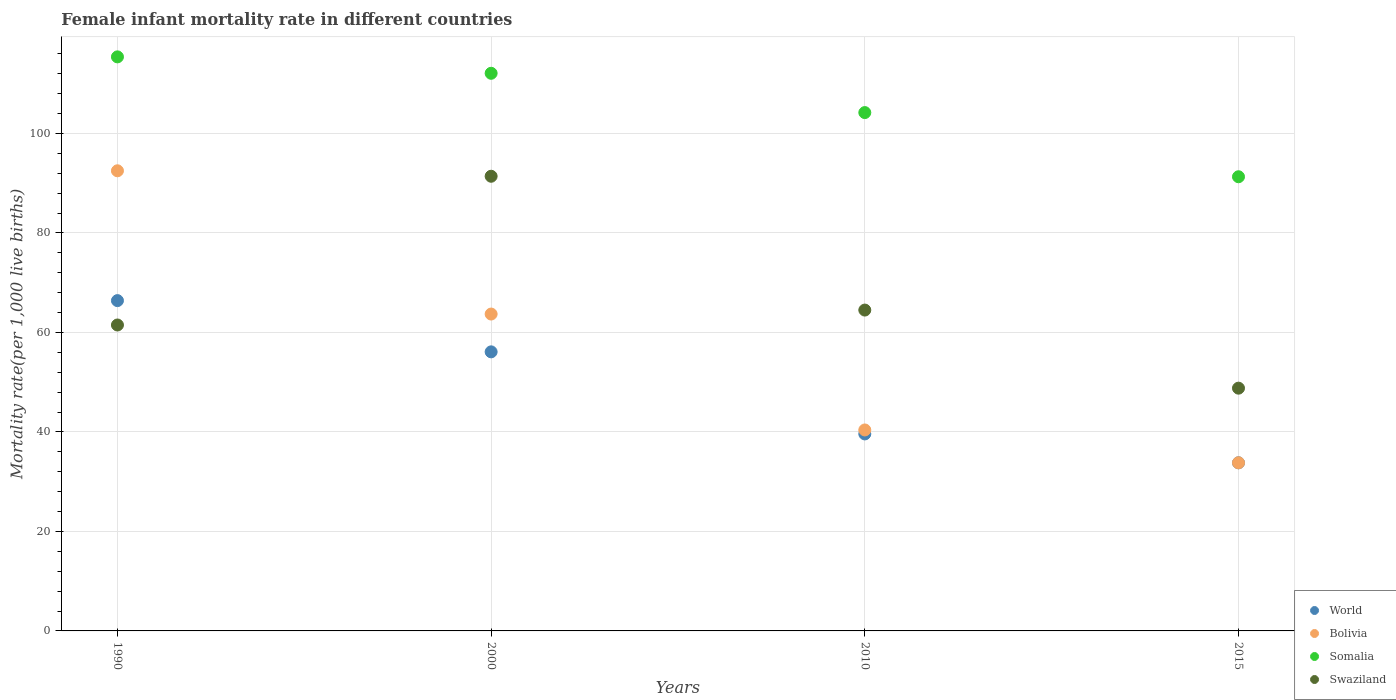How many different coloured dotlines are there?
Your response must be concise. 4. Is the number of dotlines equal to the number of legend labels?
Offer a very short reply. Yes. What is the female infant mortality rate in World in 2000?
Provide a short and direct response. 56.1. Across all years, what is the maximum female infant mortality rate in Bolivia?
Provide a succinct answer. 92.5. Across all years, what is the minimum female infant mortality rate in Somalia?
Keep it short and to the point. 91.3. In which year was the female infant mortality rate in Somalia maximum?
Your response must be concise. 1990. In which year was the female infant mortality rate in Bolivia minimum?
Make the answer very short. 2015. What is the total female infant mortality rate in Swaziland in the graph?
Your response must be concise. 266.2. What is the difference between the female infant mortality rate in Somalia in 2000 and that in 2010?
Offer a very short reply. 7.9. What is the difference between the female infant mortality rate in World in 1990 and the female infant mortality rate in Swaziland in 2010?
Provide a short and direct response. 1.9. What is the average female infant mortality rate in Somalia per year?
Make the answer very short. 105.75. In how many years, is the female infant mortality rate in Bolivia greater than 80?
Offer a very short reply. 1. What is the ratio of the female infant mortality rate in Swaziland in 1990 to that in 2000?
Your response must be concise. 0.67. Is the female infant mortality rate in Swaziland in 1990 less than that in 2010?
Provide a short and direct response. Yes. What is the difference between the highest and the second highest female infant mortality rate in Somalia?
Keep it short and to the point. 3.3. What is the difference between the highest and the lowest female infant mortality rate in Swaziland?
Your response must be concise. 42.6. In how many years, is the female infant mortality rate in Swaziland greater than the average female infant mortality rate in Swaziland taken over all years?
Provide a short and direct response. 1. Is the sum of the female infant mortality rate in Swaziland in 1990 and 2015 greater than the maximum female infant mortality rate in Bolivia across all years?
Provide a short and direct response. Yes. Is it the case that in every year, the sum of the female infant mortality rate in World and female infant mortality rate in Somalia  is greater than the female infant mortality rate in Bolivia?
Your response must be concise. Yes. Is the female infant mortality rate in Swaziland strictly less than the female infant mortality rate in Somalia over the years?
Your answer should be compact. Yes. Are the values on the major ticks of Y-axis written in scientific E-notation?
Ensure brevity in your answer.  No. Does the graph contain any zero values?
Your answer should be compact. No. Does the graph contain grids?
Provide a succinct answer. Yes. Where does the legend appear in the graph?
Your response must be concise. Bottom right. What is the title of the graph?
Your answer should be very brief. Female infant mortality rate in different countries. What is the label or title of the Y-axis?
Keep it short and to the point. Mortality rate(per 1,0 live births). What is the Mortality rate(per 1,000 live births) of World in 1990?
Your answer should be compact. 66.4. What is the Mortality rate(per 1,000 live births) of Bolivia in 1990?
Your answer should be compact. 92.5. What is the Mortality rate(per 1,000 live births) of Somalia in 1990?
Provide a short and direct response. 115.4. What is the Mortality rate(per 1,000 live births) of Swaziland in 1990?
Offer a terse response. 61.5. What is the Mortality rate(per 1,000 live births) in World in 2000?
Offer a terse response. 56.1. What is the Mortality rate(per 1,000 live births) in Bolivia in 2000?
Your answer should be very brief. 63.7. What is the Mortality rate(per 1,000 live births) of Somalia in 2000?
Your answer should be compact. 112.1. What is the Mortality rate(per 1,000 live births) of Swaziland in 2000?
Offer a very short reply. 91.4. What is the Mortality rate(per 1,000 live births) of World in 2010?
Your answer should be very brief. 39.6. What is the Mortality rate(per 1,000 live births) in Bolivia in 2010?
Offer a very short reply. 40.4. What is the Mortality rate(per 1,000 live births) of Somalia in 2010?
Offer a terse response. 104.2. What is the Mortality rate(per 1,000 live births) of Swaziland in 2010?
Your response must be concise. 64.5. What is the Mortality rate(per 1,000 live births) in World in 2015?
Your response must be concise. 33.8. What is the Mortality rate(per 1,000 live births) in Bolivia in 2015?
Keep it short and to the point. 33.8. What is the Mortality rate(per 1,000 live births) in Somalia in 2015?
Provide a succinct answer. 91.3. What is the Mortality rate(per 1,000 live births) of Swaziland in 2015?
Offer a very short reply. 48.8. Across all years, what is the maximum Mortality rate(per 1,000 live births) of World?
Provide a succinct answer. 66.4. Across all years, what is the maximum Mortality rate(per 1,000 live births) in Bolivia?
Offer a terse response. 92.5. Across all years, what is the maximum Mortality rate(per 1,000 live births) of Somalia?
Keep it short and to the point. 115.4. Across all years, what is the maximum Mortality rate(per 1,000 live births) of Swaziland?
Provide a succinct answer. 91.4. Across all years, what is the minimum Mortality rate(per 1,000 live births) of World?
Offer a very short reply. 33.8. Across all years, what is the minimum Mortality rate(per 1,000 live births) of Bolivia?
Your response must be concise. 33.8. Across all years, what is the minimum Mortality rate(per 1,000 live births) of Somalia?
Keep it short and to the point. 91.3. Across all years, what is the minimum Mortality rate(per 1,000 live births) in Swaziland?
Offer a very short reply. 48.8. What is the total Mortality rate(per 1,000 live births) of World in the graph?
Ensure brevity in your answer.  195.9. What is the total Mortality rate(per 1,000 live births) of Bolivia in the graph?
Ensure brevity in your answer.  230.4. What is the total Mortality rate(per 1,000 live births) of Somalia in the graph?
Your answer should be compact. 423. What is the total Mortality rate(per 1,000 live births) of Swaziland in the graph?
Your answer should be very brief. 266.2. What is the difference between the Mortality rate(per 1,000 live births) in Bolivia in 1990 and that in 2000?
Your answer should be very brief. 28.8. What is the difference between the Mortality rate(per 1,000 live births) of Somalia in 1990 and that in 2000?
Offer a very short reply. 3.3. What is the difference between the Mortality rate(per 1,000 live births) of Swaziland in 1990 and that in 2000?
Make the answer very short. -29.9. What is the difference between the Mortality rate(per 1,000 live births) in World in 1990 and that in 2010?
Give a very brief answer. 26.8. What is the difference between the Mortality rate(per 1,000 live births) of Bolivia in 1990 and that in 2010?
Ensure brevity in your answer.  52.1. What is the difference between the Mortality rate(per 1,000 live births) of World in 1990 and that in 2015?
Your answer should be compact. 32.6. What is the difference between the Mortality rate(per 1,000 live births) in Bolivia in 1990 and that in 2015?
Your answer should be compact. 58.7. What is the difference between the Mortality rate(per 1,000 live births) of Somalia in 1990 and that in 2015?
Your answer should be compact. 24.1. What is the difference between the Mortality rate(per 1,000 live births) in Bolivia in 2000 and that in 2010?
Your response must be concise. 23.3. What is the difference between the Mortality rate(per 1,000 live births) in Swaziland in 2000 and that in 2010?
Your response must be concise. 26.9. What is the difference between the Mortality rate(per 1,000 live births) in World in 2000 and that in 2015?
Your answer should be very brief. 22.3. What is the difference between the Mortality rate(per 1,000 live births) of Bolivia in 2000 and that in 2015?
Keep it short and to the point. 29.9. What is the difference between the Mortality rate(per 1,000 live births) of Somalia in 2000 and that in 2015?
Your answer should be compact. 20.8. What is the difference between the Mortality rate(per 1,000 live births) of Swaziland in 2000 and that in 2015?
Provide a succinct answer. 42.6. What is the difference between the Mortality rate(per 1,000 live births) of Bolivia in 2010 and that in 2015?
Your response must be concise. 6.6. What is the difference between the Mortality rate(per 1,000 live births) in Somalia in 2010 and that in 2015?
Offer a terse response. 12.9. What is the difference between the Mortality rate(per 1,000 live births) of World in 1990 and the Mortality rate(per 1,000 live births) of Bolivia in 2000?
Provide a succinct answer. 2.7. What is the difference between the Mortality rate(per 1,000 live births) of World in 1990 and the Mortality rate(per 1,000 live births) of Somalia in 2000?
Ensure brevity in your answer.  -45.7. What is the difference between the Mortality rate(per 1,000 live births) of Bolivia in 1990 and the Mortality rate(per 1,000 live births) of Somalia in 2000?
Offer a very short reply. -19.6. What is the difference between the Mortality rate(per 1,000 live births) of World in 1990 and the Mortality rate(per 1,000 live births) of Bolivia in 2010?
Give a very brief answer. 26. What is the difference between the Mortality rate(per 1,000 live births) in World in 1990 and the Mortality rate(per 1,000 live births) in Somalia in 2010?
Offer a very short reply. -37.8. What is the difference between the Mortality rate(per 1,000 live births) in World in 1990 and the Mortality rate(per 1,000 live births) in Swaziland in 2010?
Keep it short and to the point. 1.9. What is the difference between the Mortality rate(per 1,000 live births) of Bolivia in 1990 and the Mortality rate(per 1,000 live births) of Somalia in 2010?
Offer a terse response. -11.7. What is the difference between the Mortality rate(per 1,000 live births) of Bolivia in 1990 and the Mortality rate(per 1,000 live births) of Swaziland in 2010?
Offer a very short reply. 28. What is the difference between the Mortality rate(per 1,000 live births) in Somalia in 1990 and the Mortality rate(per 1,000 live births) in Swaziland in 2010?
Provide a succinct answer. 50.9. What is the difference between the Mortality rate(per 1,000 live births) of World in 1990 and the Mortality rate(per 1,000 live births) of Bolivia in 2015?
Your answer should be very brief. 32.6. What is the difference between the Mortality rate(per 1,000 live births) of World in 1990 and the Mortality rate(per 1,000 live births) of Somalia in 2015?
Keep it short and to the point. -24.9. What is the difference between the Mortality rate(per 1,000 live births) in Bolivia in 1990 and the Mortality rate(per 1,000 live births) in Swaziland in 2015?
Ensure brevity in your answer.  43.7. What is the difference between the Mortality rate(per 1,000 live births) of Somalia in 1990 and the Mortality rate(per 1,000 live births) of Swaziland in 2015?
Your answer should be compact. 66.6. What is the difference between the Mortality rate(per 1,000 live births) in World in 2000 and the Mortality rate(per 1,000 live births) in Bolivia in 2010?
Offer a very short reply. 15.7. What is the difference between the Mortality rate(per 1,000 live births) in World in 2000 and the Mortality rate(per 1,000 live births) in Somalia in 2010?
Your response must be concise. -48.1. What is the difference between the Mortality rate(per 1,000 live births) in Bolivia in 2000 and the Mortality rate(per 1,000 live births) in Somalia in 2010?
Keep it short and to the point. -40.5. What is the difference between the Mortality rate(per 1,000 live births) of Somalia in 2000 and the Mortality rate(per 1,000 live births) of Swaziland in 2010?
Your answer should be very brief. 47.6. What is the difference between the Mortality rate(per 1,000 live births) in World in 2000 and the Mortality rate(per 1,000 live births) in Bolivia in 2015?
Give a very brief answer. 22.3. What is the difference between the Mortality rate(per 1,000 live births) in World in 2000 and the Mortality rate(per 1,000 live births) in Somalia in 2015?
Provide a succinct answer. -35.2. What is the difference between the Mortality rate(per 1,000 live births) of World in 2000 and the Mortality rate(per 1,000 live births) of Swaziland in 2015?
Give a very brief answer. 7.3. What is the difference between the Mortality rate(per 1,000 live births) in Bolivia in 2000 and the Mortality rate(per 1,000 live births) in Somalia in 2015?
Provide a succinct answer. -27.6. What is the difference between the Mortality rate(per 1,000 live births) of Somalia in 2000 and the Mortality rate(per 1,000 live births) of Swaziland in 2015?
Keep it short and to the point. 63.3. What is the difference between the Mortality rate(per 1,000 live births) of World in 2010 and the Mortality rate(per 1,000 live births) of Somalia in 2015?
Keep it short and to the point. -51.7. What is the difference between the Mortality rate(per 1,000 live births) of Bolivia in 2010 and the Mortality rate(per 1,000 live births) of Somalia in 2015?
Keep it short and to the point. -50.9. What is the difference between the Mortality rate(per 1,000 live births) of Bolivia in 2010 and the Mortality rate(per 1,000 live births) of Swaziland in 2015?
Offer a very short reply. -8.4. What is the difference between the Mortality rate(per 1,000 live births) in Somalia in 2010 and the Mortality rate(per 1,000 live births) in Swaziland in 2015?
Keep it short and to the point. 55.4. What is the average Mortality rate(per 1,000 live births) in World per year?
Your answer should be compact. 48.98. What is the average Mortality rate(per 1,000 live births) of Bolivia per year?
Ensure brevity in your answer.  57.6. What is the average Mortality rate(per 1,000 live births) in Somalia per year?
Keep it short and to the point. 105.75. What is the average Mortality rate(per 1,000 live births) in Swaziland per year?
Ensure brevity in your answer.  66.55. In the year 1990, what is the difference between the Mortality rate(per 1,000 live births) of World and Mortality rate(per 1,000 live births) of Bolivia?
Your answer should be very brief. -26.1. In the year 1990, what is the difference between the Mortality rate(per 1,000 live births) of World and Mortality rate(per 1,000 live births) of Somalia?
Your response must be concise. -49. In the year 1990, what is the difference between the Mortality rate(per 1,000 live births) of World and Mortality rate(per 1,000 live births) of Swaziland?
Provide a succinct answer. 4.9. In the year 1990, what is the difference between the Mortality rate(per 1,000 live births) in Bolivia and Mortality rate(per 1,000 live births) in Somalia?
Provide a short and direct response. -22.9. In the year 1990, what is the difference between the Mortality rate(per 1,000 live births) of Somalia and Mortality rate(per 1,000 live births) of Swaziland?
Your response must be concise. 53.9. In the year 2000, what is the difference between the Mortality rate(per 1,000 live births) in World and Mortality rate(per 1,000 live births) in Somalia?
Provide a short and direct response. -56. In the year 2000, what is the difference between the Mortality rate(per 1,000 live births) in World and Mortality rate(per 1,000 live births) in Swaziland?
Provide a succinct answer. -35.3. In the year 2000, what is the difference between the Mortality rate(per 1,000 live births) of Bolivia and Mortality rate(per 1,000 live births) of Somalia?
Provide a succinct answer. -48.4. In the year 2000, what is the difference between the Mortality rate(per 1,000 live births) in Bolivia and Mortality rate(per 1,000 live births) in Swaziland?
Provide a succinct answer. -27.7. In the year 2000, what is the difference between the Mortality rate(per 1,000 live births) in Somalia and Mortality rate(per 1,000 live births) in Swaziland?
Offer a very short reply. 20.7. In the year 2010, what is the difference between the Mortality rate(per 1,000 live births) in World and Mortality rate(per 1,000 live births) in Bolivia?
Your response must be concise. -0.8. In the year 2010, what is the difference between the Mortality rate(per 1,000 live births) of World and Mortality rate(per 1,000 live births) of Somalia?
Keep it short and to the point. -64.6. In the year 2010, what is the difference between the Mortality rate(per 1,000 live births) in World and Mortality rate(per 1,000 live births) in Swaziland?
Give a very brief answer. -24.9. In the year 2010, what is the difference between the Mortality rate(per 1,000 live births) in Bolivia and Mortality rate(per 1,000 live births) in Somalia?
Offer a very short reply. -63.8. In the year 2010, what is the difference between the Mortality rate(per 1,000 live births) in Bolivia and Mortality rate(per 1,000 live births) in Swaziland?
Offer a very short reply. -24.1. In the year 2010, what is the difference between the Mortality rate(per 1,000 live births) in Somalia and Mortality rate(per 1,000 live births) in Swaziland?
Give a very brief answer. 39.7. In the year 2015, what is the difference between the Mortality rate(per 1,000 live births) in World and Mortality rate(per 1,000 live births) in Somalia?
Offer a terse response. -57.5. In the year 2015, what is the difference between the Mortality rate(per 1,000 live births) of Bolivia and Mortality rate(per 1,000 live births) of Somalia?
Your answer should be compact. -57.5. In the year 2015, what is the difference between the Mortality rate(per 1,000 live births) of Bolivia and Mortality rate(per 1,000 live births) of Swaziland?
Keep it short and to the point. -15. In the year 2015, what is the difference between the Mortality rate(per 1,000 live births) in Somalia and Mortality rate(per 1,000 live births) in Swaziland?
Your response must be concise. 42.5. What is the ratio of the Mortality rate(per 1,000 live births) of World in 1990 to that in 2000?
Make the answer very short. 1.18. What is the ratio of the Mortality rate(per 1,000 live births) of Bolivia in 1990 to that in 2000?
Ensure brevity in your answer.  1.45. What is the ratio of the Mortality rate(per 1,000 live births) in Somalia in 1990 to that in 2000?
Your answer should be very brief. 1.03. What is the ratio of the Mortality rate(per 1,000 live births) of Swaziland in 1990 to that in 2000?
Ensure brevity in your answer.  0.67. What is the ratio of the Mortality rate(per 1,000 live births) in World in 1990 to that in 2010?
Provide a succinct answer. 1.68. What is the ratio of the Mortality rate(per 1,000 live births) of Bolivia in 1990 to that in 2010?
Provide a short and direct response. 2.29. What is the ratio of the Mortality rate(per 1,000 live births) of Somalia in 1990 to that in 2010?
Ensure brevity in your answer.  1.11. What is the ratio of the Mortality rate(per 1,000 live births) of Swaziland in 1990 to that in 2010?
Make the answer very short. 0.95. What is the ratio of the Mortality rate(per 1,000 live births) in World in 1990 to that in 2015?
Offer a very short reply. 1.96. What is the ratio of the Mortality rate(per 1,000 live births) in Bolivia in 1990 to that in 2015?
Ensure brevity in your answer.  2.74. What is the ratio of the Mortality rate(per 1,000 live births) in Somalia in 1990 to that in 2015?
Your answer should be very brief. 1.26. What is the ratio of the Mortality rate(per 1,000 live births) in Swaziland in 1990 to that in 2015?
Offer a terse response. 1.26. What is the ratio of the Mortality rate(per 1,000 live births) of World in 2000 to that in 2010?
Offer a terse response. 1.42. What is the ratio of the Mortality rate(per 1,000 live births) of Bolivia in 2000 to that in 2010?
Offer a very short reply. 1.58. What is the ratio of the Mortality rate(per 1,000 live births) of Somalia in 2000 to that in 2010?
Provide a succinct answer. 1.08. What is the ratio of the Mortality rate(per 1,000 live births) of Swaziland in 2000 to that in 2010?
Your answer should be compact. 1.42. What is the ratio of the Mortality rate(per 1,000 live births) of World in 2000 to that in 2015?
Your answer should be very brief. 1.66. What is the ratio of the Mortality rate(per 1,000 live births) of Bolivia in 2000 to that in 2015?
Provide a succinct answer. 1.88. What is the ratio of the Mortality rate(per 1,000 live births) in Somalia in 2000 to that in 2015?
Keep it short and to the point. 1.23. What is the ratio of the Mortality rate(per 1,000 live births) of Swaziland in 2000 to that in 2015?
Provide a short and direct response. 1.87. What is the ratio of the Mortality rate(per 1,000 live births) in World in 2010 to that in 2015?
Make the answer very short. 1.17. What is the ratio of the Mortality rate(per 1,000 live births) of Bolivia in 2010 to that in 2015?
Make the answer very short. 1.2. What is the ratio of the Mortality rate(per 1,000 live births) in Somalia in 2010 to that in 2015?
Offer a very short reply. 1.14. What is the ratio of the Mortality rate(per 1,000 live births) in Swaziland in 2010 to that in 2015?
Your answer should be compact. 1.32. What is the difference between the highest and the second highest Mortality rate(per 1,000 live births) in World?
Provide a short and direct response. 10.3. What is the difference between the highest and the second highest Mortality rate(per 1,000 live births) in Bolivia?
Offer a very short reply. 28.8. What is the difference between the highest and the second highest Mortality rate(per 1,000 live births) of Somalia?
Make the answer very short. 3.3. What is the difference between the highest and the second highest Mortality rate(per 1,000 live births) in Swaziland?
Give a very brief answer. 26.9. What is the difference between the highest and the lowest Mortality rate(per 1,000 live births) in World?
Offer a terse response. 32.6. What is the difference between the highest and the lowest Mortality rate(per 1,000 live births) of Bolivia?
Give a very brief answer. 58.7. What is the difference between the highest and the lowest Mortality rate(per 1,000 live births) in Somalia?
Your answer should be very brief. 24.1. What is the difference between the highest and the lowest Mortality rate(per 1,000 live births) in Swaziland?
Your answer should be compact. 42.6. 